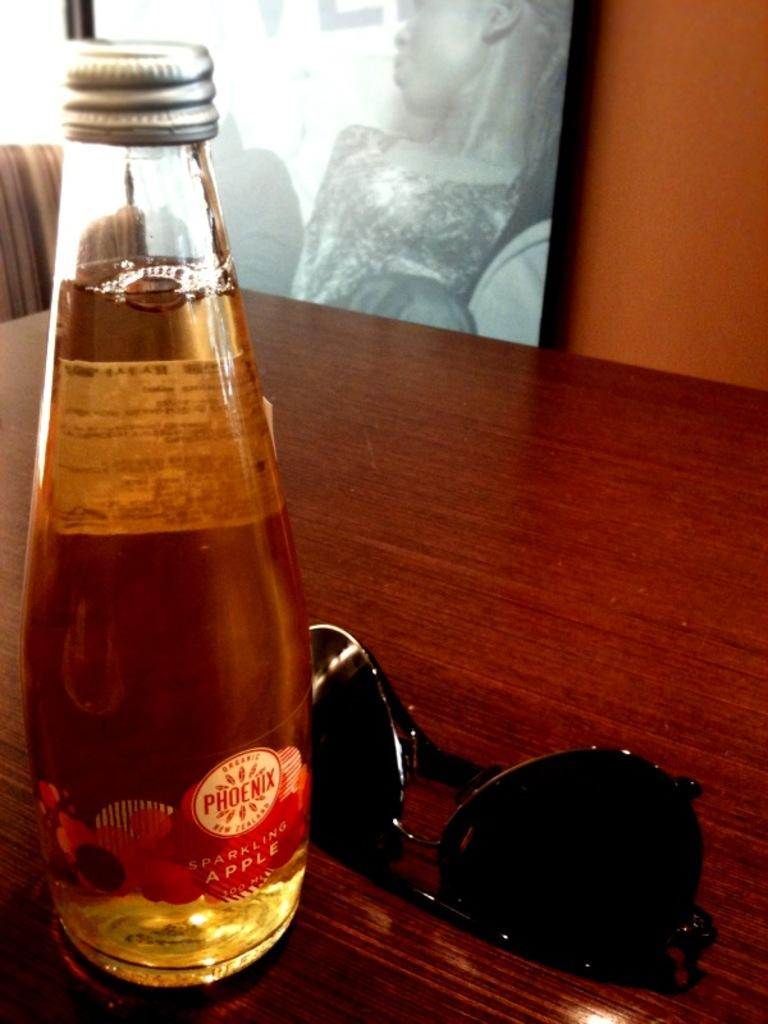<image>
Summarize the visual content of the image. A bottle of Phoenix sparkling apple juice sits next to some sunglasses. 